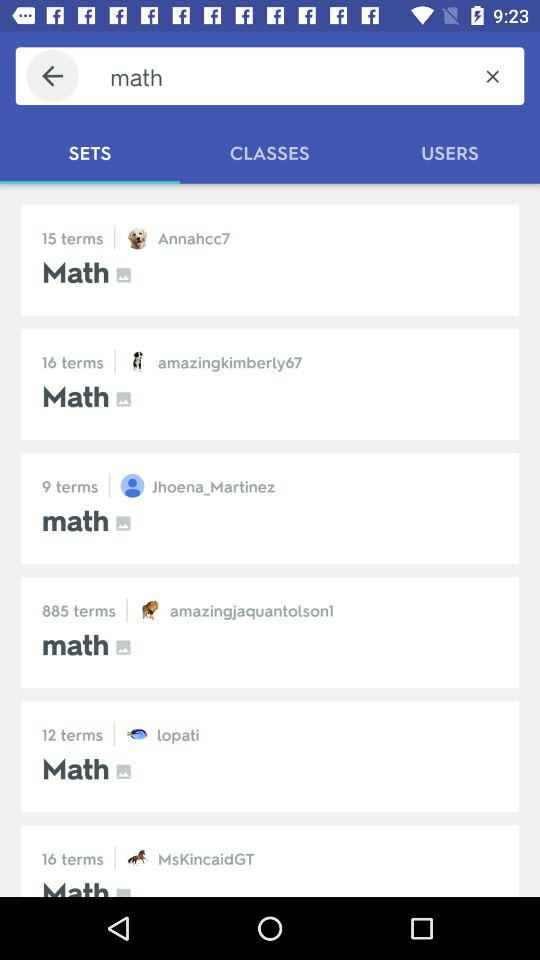Which tab is selected? The selected tab is "SETS". 